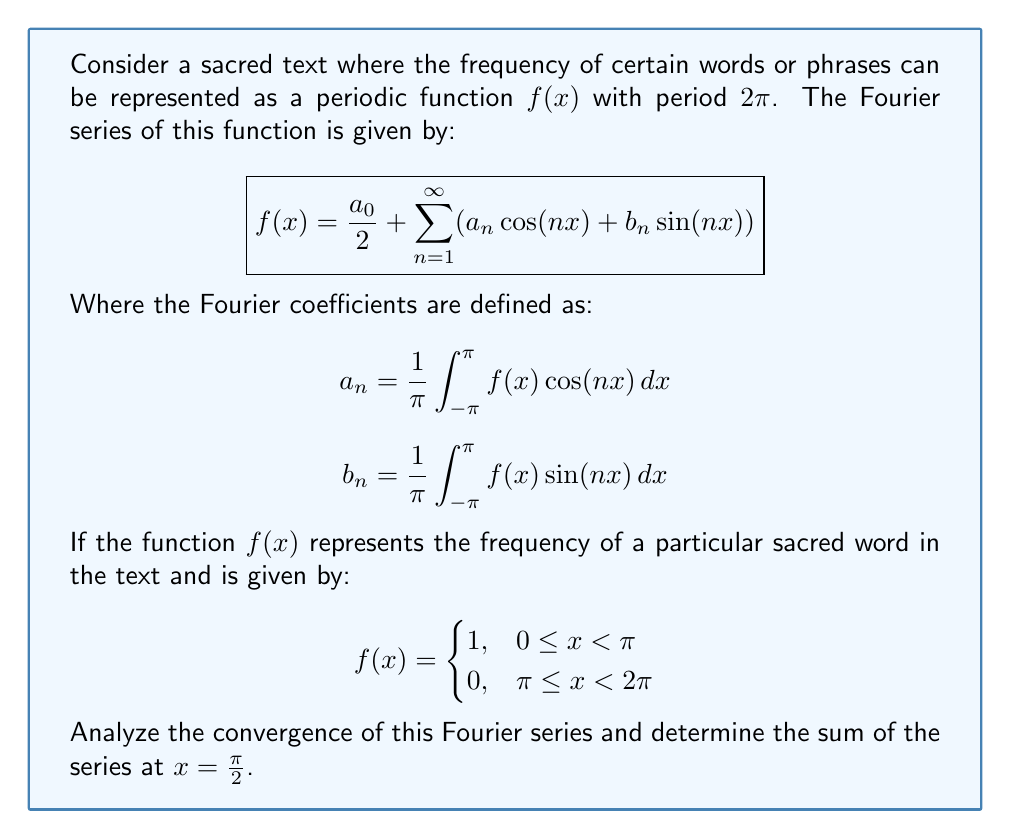Give your solution to this math problem. To analyze the convergence and sum of the Fourier series, we'll follow these steps:

1) First, let's calculate the Fourier coefficients:

   For $a_0$:
   $$a_0 = \frac{1}{\pi} \int_{0}^{\pi} 1 dx + \frac{1}{\pi} \int_{\pi}^{2\pi} 0 dx = 1$$

   For $a_n$ (n > 0):
   $$a_n = \frac{1}{\pi} \int_{0}^{\pi} \cos(nx) dx = \frac{1}{n\pi} [\sin(nx)]_0^{\pi} = 0$$

   For $b_n$:
   $$b_n = \frac{1}{\pi} \int_{0}^{\pi} \sin(nx) dx = \frac{1}{n\pi} [-\cos(nx)]_0^{\pi} = \frac{1-(-1)^n}{n\pi}$$

2) The Fourier series becomes:

   $$f(x) = \frac{1}{2} + \sum_{n=1}^{\infty} \frac{1-(-1)^n}{n\pi} \sin(nx)$$

3) To analyze convergence, we can use Dirichlet's test. The series converges for all x except at the jump discontinuities (x = 0, π, 2π).

4) At $x = \frac{\pi}{2}$, the series becomes:

   $$f(\frac{\pi}{2}) = \frac{1}{2} + \sum_{n=1}^{\infty} \frac{1-(-1)^n}{n\pi} \sin(\frac{n\pi}{2})$$

5) Simplify:
   - When n is odd, $\sin(\frac{n\pi}{2}) = (-1)^{\frac{n-1}{2}}$ and $1-(-1)^n = 2$
   - When n is even, $\sin(\frac{n\pi}{2}) = 0$

   So, the series reduces to:

   $$f(\frac{\pi}{2}) = \frac{1}{2} + \frac{2}{\pi} \sum_{k=0}^{\infty} \frac{(-1)^k}{2k+1}$$

6) The sum $\sum_{k=0}^{\infty} \frac{(-1)^k}{2k+1} = \frac{\pi}{4}$

Therefore, $f(\frac{\pi}{2}) = \frac{1}{2} + \frac{2}{\pi} \cdot \frac{\pi}{4} = 1$

This result aligns with the original function definition, confirming the convergence and accuracy of the Fourier series representation.
Answer: $f(\frac{\pi}{2}) = 1$ 